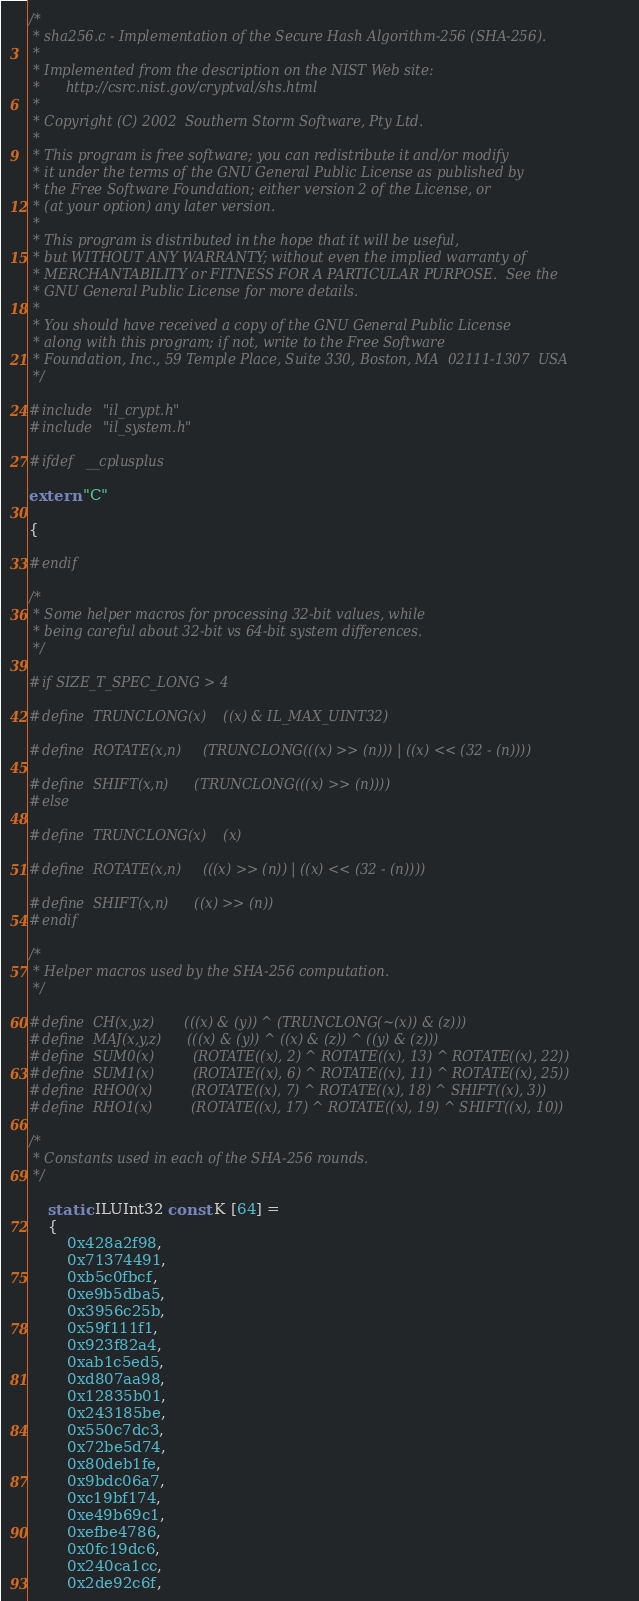Convert code to text. <code><loc_0><loc_0><loc_500><loc_500><_C_>/*
 * sha256.c - Implementation of the Secure Hash Algorithm-256 (SHA-256).
 *
 * Implemented from the description on the NIST Web site:
 *		http://csrc.nist.gov/cryptval/shs.html
 *
 * Copyright (C) 2002  Southern Storm Software, Pty Ltd.
 *
 * This program is free software; you can redistribute it and/or modify
 * it under the terms of the GNU General Public License as published by
 * the Free Software Foundation; either version 2 of the License, or
 * (at your option) any later version.
 *
 * This program is distributed in the hope that it will be useful,
 * but WITHOUT ANY WARRANTY; without even the implied warranty of
 * MERCHANTABILITY or FITNESS FOR A PARTICULAR PURPOSE.  See the
 * GNU General Public License for more details.
 *
 * You should have received a copy of the GNU General Public License
 * along with this program; if not, write to the Free Software
 * Foundation, Inc., 59 Temple Place, Suite 330, Boston, MA  02111-1307  USA
 */

#include "il_crypt.h"
#include "il_system.h"

#ifdef	__cplusplus

extern "C" 

{

#endif

/*
 * Some helper macros for processing 32-bit values, while
 * being careful about 32-bit vs 64-bit system differences.
 */

#if SIZE_T_SPEC_LONG > 4

#define	TRUNCLONG(x)	((x) & IL_MAX_UINT32)

#define	ROTATE(x,n)		(TRUNCLONG(((x) >> (n))) | ((x) << (32 - (n))))

#define	SHIFT(x,n)		(TRUNCLONG(((x) >> (n))))
#else

#define	TRUNCLONG(x)	(x)

#define	ROTATE(x,n)		(((x) >> (n)) | ((x) << (32 - (n))))

#define	SHIFT(x,n)		((x) >> (n))
#endif

/*
 * Helper macros used by the SHA-256 computation.
 */

#define	CH(x,y,z)		(((x) & (y)) ^ (TRUNCLONG(~(x)) & (z)))
#define	MAJ(x,y,z)		(((x) & (y)) ^ ((x) & (z)) ^ ((y) & (z)))
#define	SUM0(x)			(ROTATE((x), 2) ^ ROTATE((x), 13) ^ ROTATE((x), 22))
#define	SUM1(x)			(ROTATE((x), 6) ^ ROTATE((x), 11) ^ ROTATE((x), 25))
#define	RHO0(x)			(ROTATE((x), 7) ^ ROTATE((x), 18) ^ SHIFT((x), 3))
#define	RHO1(x)			(ROTATE((x), 17) ^ ROTATE((x), 19) ^ SHIFT((x), 10))

/*
 * Constants used in each of the SHA-256 rounds.
 */

	static ILUInt32 const K [64] = 
	{
		0x428a2f98,
		0x71374491,
		0xb5c0fbcf,
		0xe9b5dba5,
		0x3956c25b,
		0x59f111f1,
		0x923f82a4,
		0xab1c5ed5,
		0xd807aa98,
		0x12835b01,
		0x243185be,
		0x550c7dc3,
		0x72be5d74,
		0x80deb1fe,
		0x9bdc06a7,
		0xc19bf174,
		0xe49b69c1,
		0xefbe4786,
		0x0fc19dc6,
		0x240ca1cc,
		0x2de92c6f,</code> 